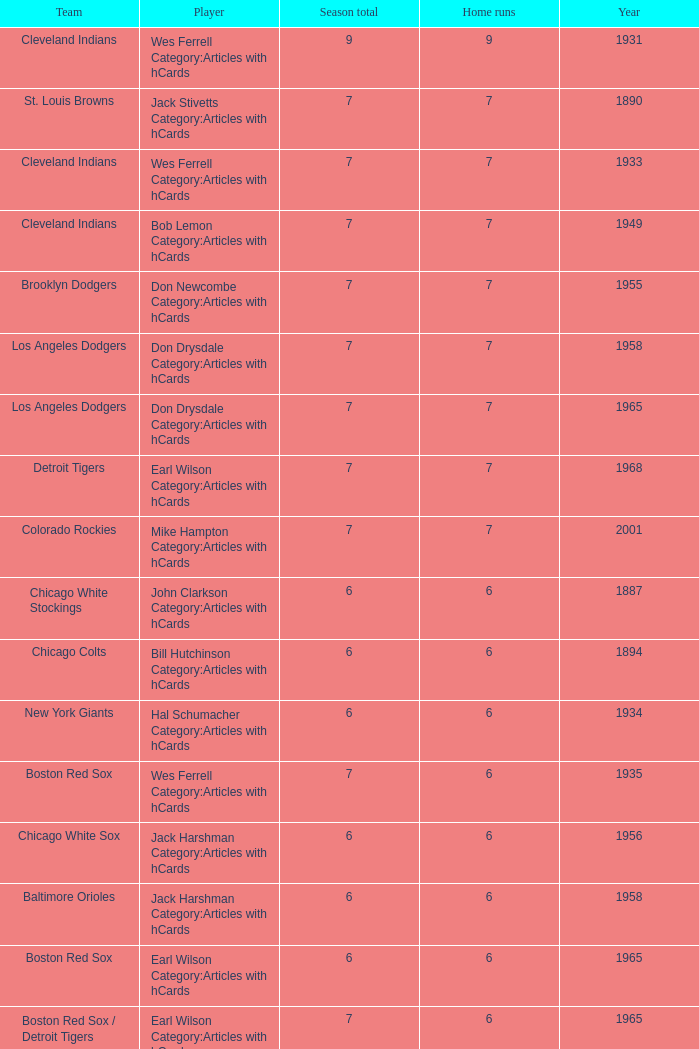Could you help me parse every detail presented in this table? {'header': ['Team', 'Player', 'Season total', 'Home runs', 'Year'], 'rows': [['Cleveland Indians', 'Wes Ferrell Category:Articles with hCards', '9', '9', '1931'], ['St. Louis Browns', 'Jack Stivetts Category:Articles with hCards', '7', '7', '1890'], ['Cleveland Indians', 'Wes Ferrell Category:Articles with hCards', '7', '7', '1933'], ['Cleveland Indians', 'Bob Lemon Category:Articles with hCards', '7', '7', '1949'], ['Brooklyn Dodgers', 'Don Newcombe Category:Articles with hCards', '7', '7', '1955'], ['Los Angeles Dodgers', 'Don Drysdale Category:Articles with hCards', '7', '7', '1958'], ['Los Angeles Dodgers', 'Don Drysdale Category:Articles with hCards', '7', '7', '1965'], ['Detroit Tigers', 'Earl Wilson Category:Articles with hCards', '7', '7', '1968'], ['Colorado Rockies', 'Mike Hampton Category:Articles with hCards', '7', '7', '2001'], ['Chicago White Stockings', 'John Clarkson Category:Articles with hCards', '6', '6', '1887'], ['Chicago Colts', 'Bill Hutchinson Category:Articles with hCards', '6', '6', '1894'], ['New York Giants', 'Hal Schumacher Category:Articles with hCards', '6', '6', '1934'], ['Boston Red Sox', 'Wes Ferrell Category:Articles with hCards', '7', '6', '1935'], ['Chicago White Sox', 'Jack Harshman Category:Articles with hCards', '6', '6', '1956'], ['Baltimore Orioles', 'Jack Harshman Category:Articles with hCards', '6', '6', '1958'], ['Boston Red Sox', 'Earl Wilson Category:Articles with hCards', '6', '6', '1965'], ['Boston Red Sox / Detroit Tigers', 'Earl Wilson Category:Articles with hCards', '7', '6', '1965'], ['Chicago Cubs', 'Ferguson Jenkins Category:Articles with hCards', '6', '6', '1971'], ['Boston Red Sox', 'Sonny Siebert Category:Articles with hCards', '6', '6', '1971'], ['Philadelphia Phillies', 'Rick Wise Category:Articles with hCards', '6', '6', '1971'], ['Chicago Cubs', 'Carlos Zambrano Category:Articles with hCards §', '6', '6', '2006']]} Tell me the highest home runs for cleveland indians years before 1931 None. 